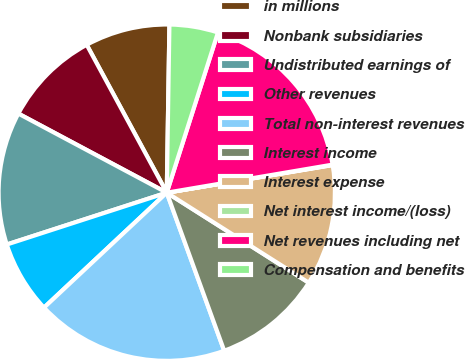Convert chart. <chart><loc_0><loc_0><loc_500><loc_500><pie_chart><fcel>in millions<fcel>Nonbank subsidiaries<fcel>Undistributed earnings of<fcel>Other revenues<fcel>Total non-interest revenues<fcel>Interest income<fcel>Interest expense<fcel>Net interest income/(loss)<fcel>Net revenues including net<fcel>Compensation and benefits<nl><fcel>8.15%<fcel>9.31%<fcel>12.78%<fcel>6.99%<fcel>18.57%<fcel>10.46%<fcel>11.62%<fcel>0.04%<fcel>17.41%<fcel>4.67%<nl></chart> 